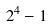Convert formula to latex. <formula><loc_0><loc_0><loc_500><loc_500>2 ^ { 4 } - 1</formula> 